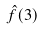Convert formula to latex. <formula><loc_0><loc_0><loc_500><loc_500>\hat { f } ( 3 )</formula> 